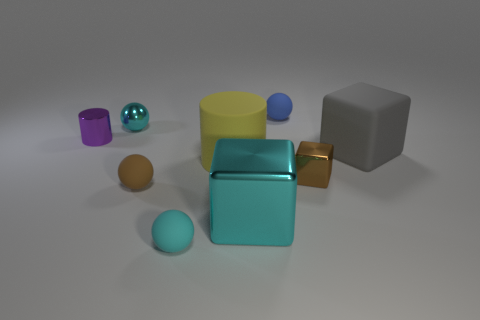Subtract all matte blocks. How many blocks are left? 2 Add 1 purple metallic objects. How many objects exist? 10 Subtract all brown balls. How many balls are left? 3 Subtract all balls. How many objects are left? 5 Subtract 1 cubes. How many cubes are left? 2 Add 4 cyan blocks. How many cyan blocks are left? 5 Add 3 purple cylinders. How many purple cylinders exist? 4 Subtract 0 red balls. How many objects are left? 9 Subtract all gray blocks. Subtract all gray spheres. How many blocks are left? 2 Subtract all red spheres. How many purple cylinders are left? 1 